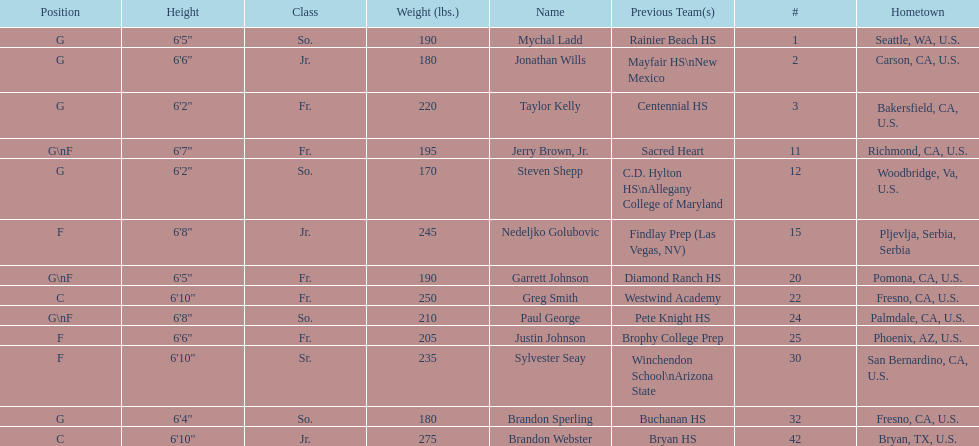Which player who is only a forward (f) is the shortest? Justin Johnson. 